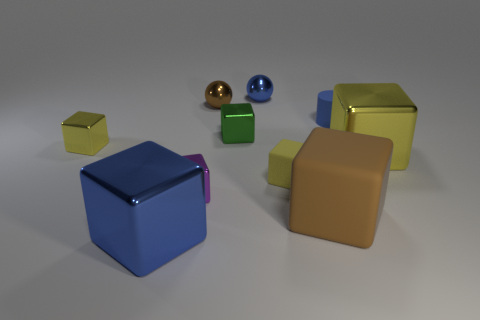How many yellow blocks must be subtracted to get 1 yellow blocks? 2 Subtract all blue balls. How many yellow cubes are left? 3 Subtract all brown cubes. How many cubes are left? 6 Subtract all purple blocks. How many blocks are left? 6 Subtract all gray cubes. Subtract all gray balls. How many cubes are left? 7 Subtract all balls. How many objects are left? 8 Subtract all blue rubber cylinders. Subtract all blue rubber cylinders. How many objects are left? 8 Add 3 small purple things. How many small purple things are left? 4 Add 2 purple cubes. How many purple cubes exist? 3 Subtract 0 gray cylinders. How many objects are left? 10 